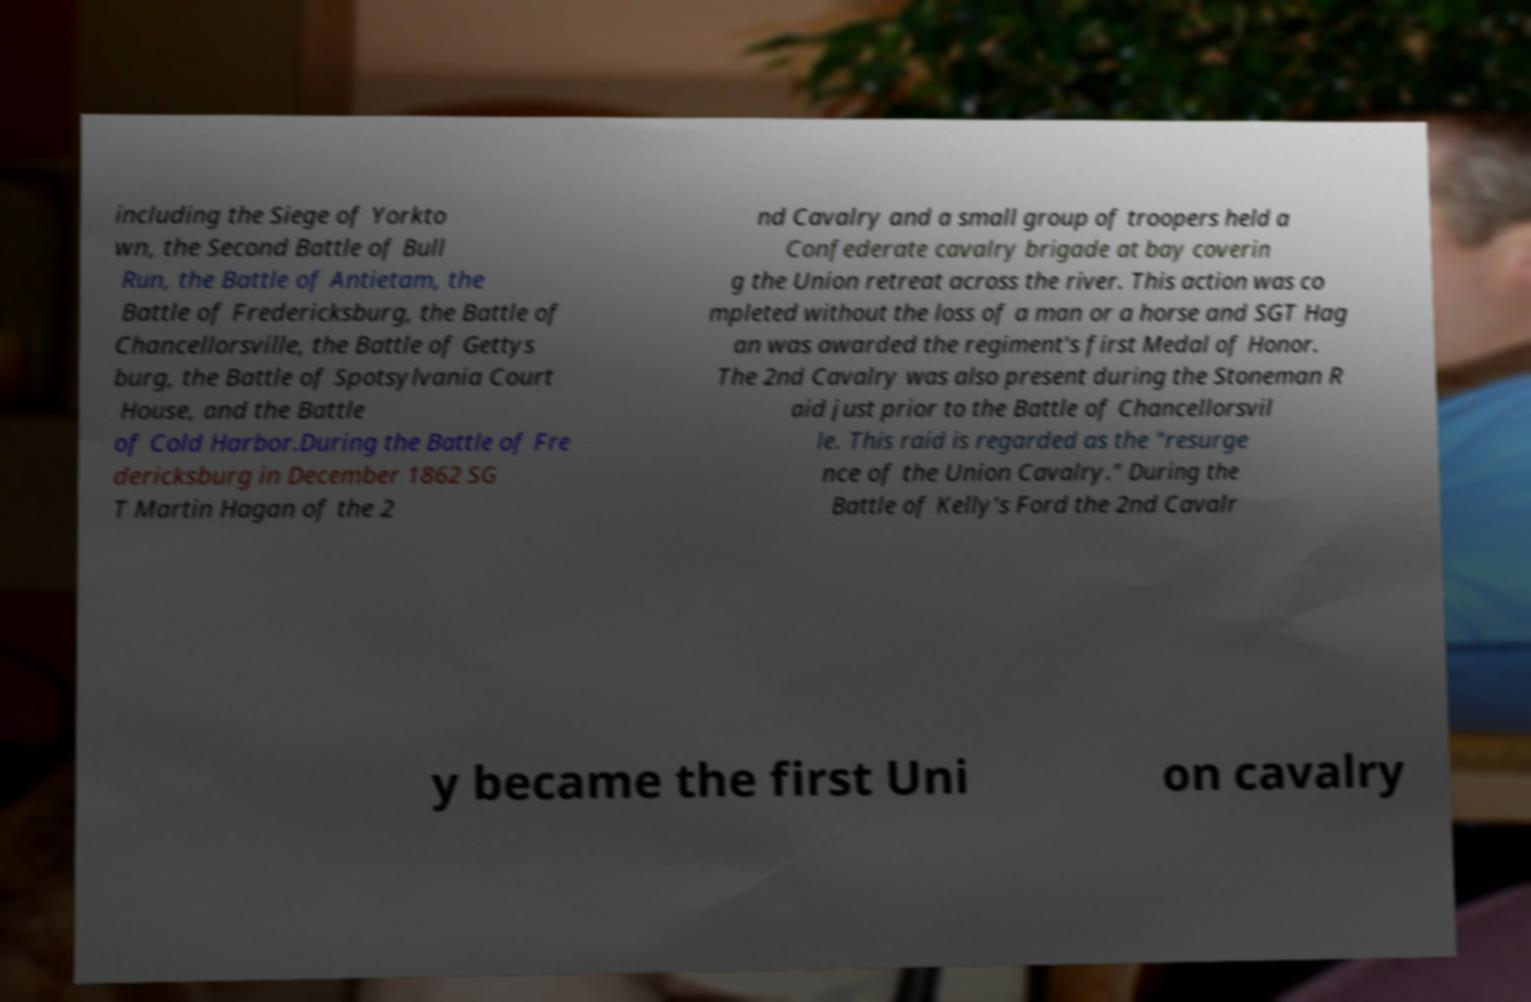For documentation purposes, I need the text within this image transcribed. Could you provide that? including the Siege of Yorkto wn, the Second Battle of Bull Run, the Battle of Antietam, the Battle of Fredericksburg, the Battle of Chancellorsville, the Battle of Gettys burg, the Battle of Spotsylvania Court House, and the Battle of Cold Harbor.During the Battle of Fre dericksburg in December 1862 SG T Martin Hagan of the 2 nd Cavalry and a small group of troopers held a Confederate cavalry brigade at bay coverin g the Union retreat across the river. This action was co mpleted without the loss of a man or a horse and SGT Hag an was awarded the regiment's first Medal of Honor. The 2nd Cavalry was also present during the Stoneman R aid just prior to the Battle of Chancellorsvil le. This raid is regarded as the "resurge nce of the Union Cavalry." During the Battle of Kelly's Ford the 2nd Cavalr y became the first Uni on cavalry 